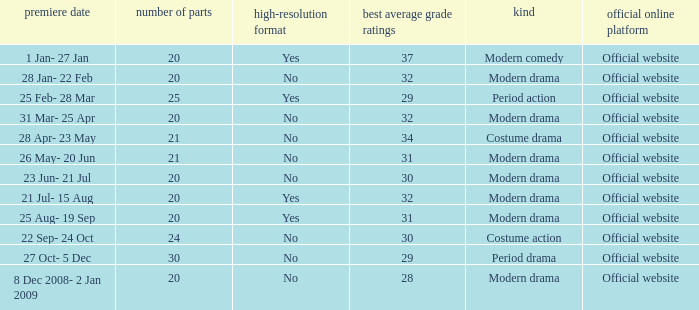What are the number of episodes when the genre is modern drama and the highest average ratings points are 28? 20.0. 